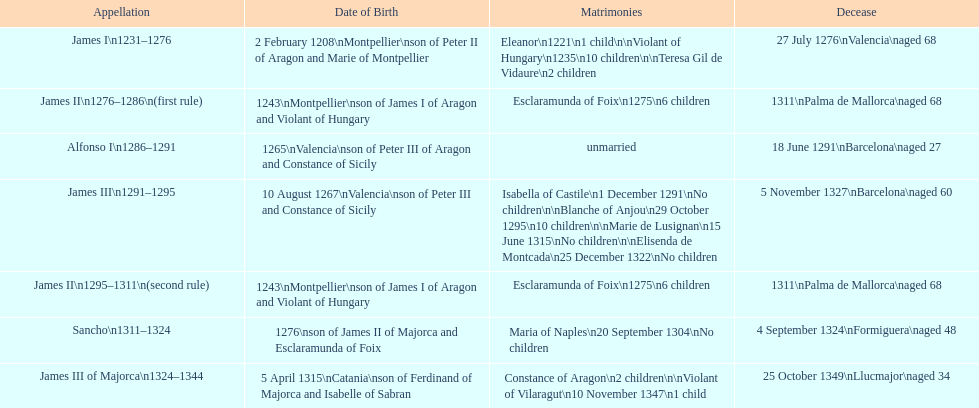Who came to power after the rule of james iii? James II. 